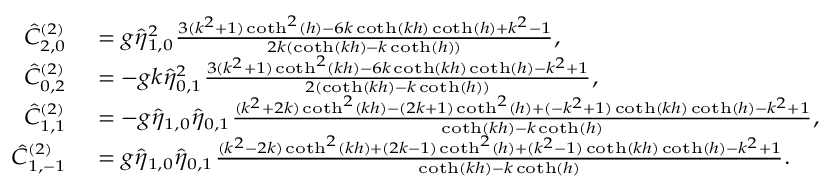Convert formula to latex. <formula><loc_0><loc_0><loc_500><loc_500>{ \begin{array} { r l } { \hat { C } _ { 2 , 0 } ^ { ( 2 ) } } & { = g \hat { \eta } _ { 1 , 0 } ^ { 2 } \frac { 3 ( k ^ { 2 } + 1 ) \coth ^ { 2 } ( h ) - 6 k \coth ( k h ) \coth ( h ) + k ^ { 2 } - 1 } { 2 k ( \coth ( k h ) - k \coth ( h ) ) } , } \\ { \hat { C } _ { 0 , 2 } ^ { ( 2 ) } } & { = - g k \hat { \eta } _ { 0 , 1 } ^ { 2 } \frac { 3 ( k ^ { 2 } + 1 ) \coth ^ { 2 } ( k h ) - 6 k \coth ( k h ) \coth ( h ) - k ^ { 2 } + 1 } { 2 ( \coth ( k h ) - k \coth ( h ) ) } , } \\ { \hat { C } _ { 1 , 1 } ^ { ( 2 ) } } & { = - g \hat { \eta } _ { 1 , 0 } \hat { \eta } _ { 0 , 1 } \frac { ( k ^ { 2 } + 2 k ) \coth ^ { 2 } ( k h ) - ( 2 k + 1 ) \coth ^ { 2 } ( h ) + ( - k ^ { 2 } + 1 ) \coth ( k h ) \coth ( h ) - k ^ { 2 } + 1 } { \coth ( k h ) - k \coth ( h ) } , } \\ { \hat { C } _ { 1 , - 1 } ^ { ( 2 ) } } & { = g \hat { \eta } _ { 1 , 0 } \hat { \eta } _ { 0 , 1 } \frac { ( k ^ { 2 } - 2 k ) \coth ^ { 2 } ( k h ) + ( 2 k - 1 ) \coth ^ { 2 } ( h ) + ( k ^ { 2 } - 1 ) \coth ( k h ) \coth ( h ) - k ^ { 2 } + 1 } { \coth ( k h ) - k \coth ( h ) } . } \end{array} }</formula> 